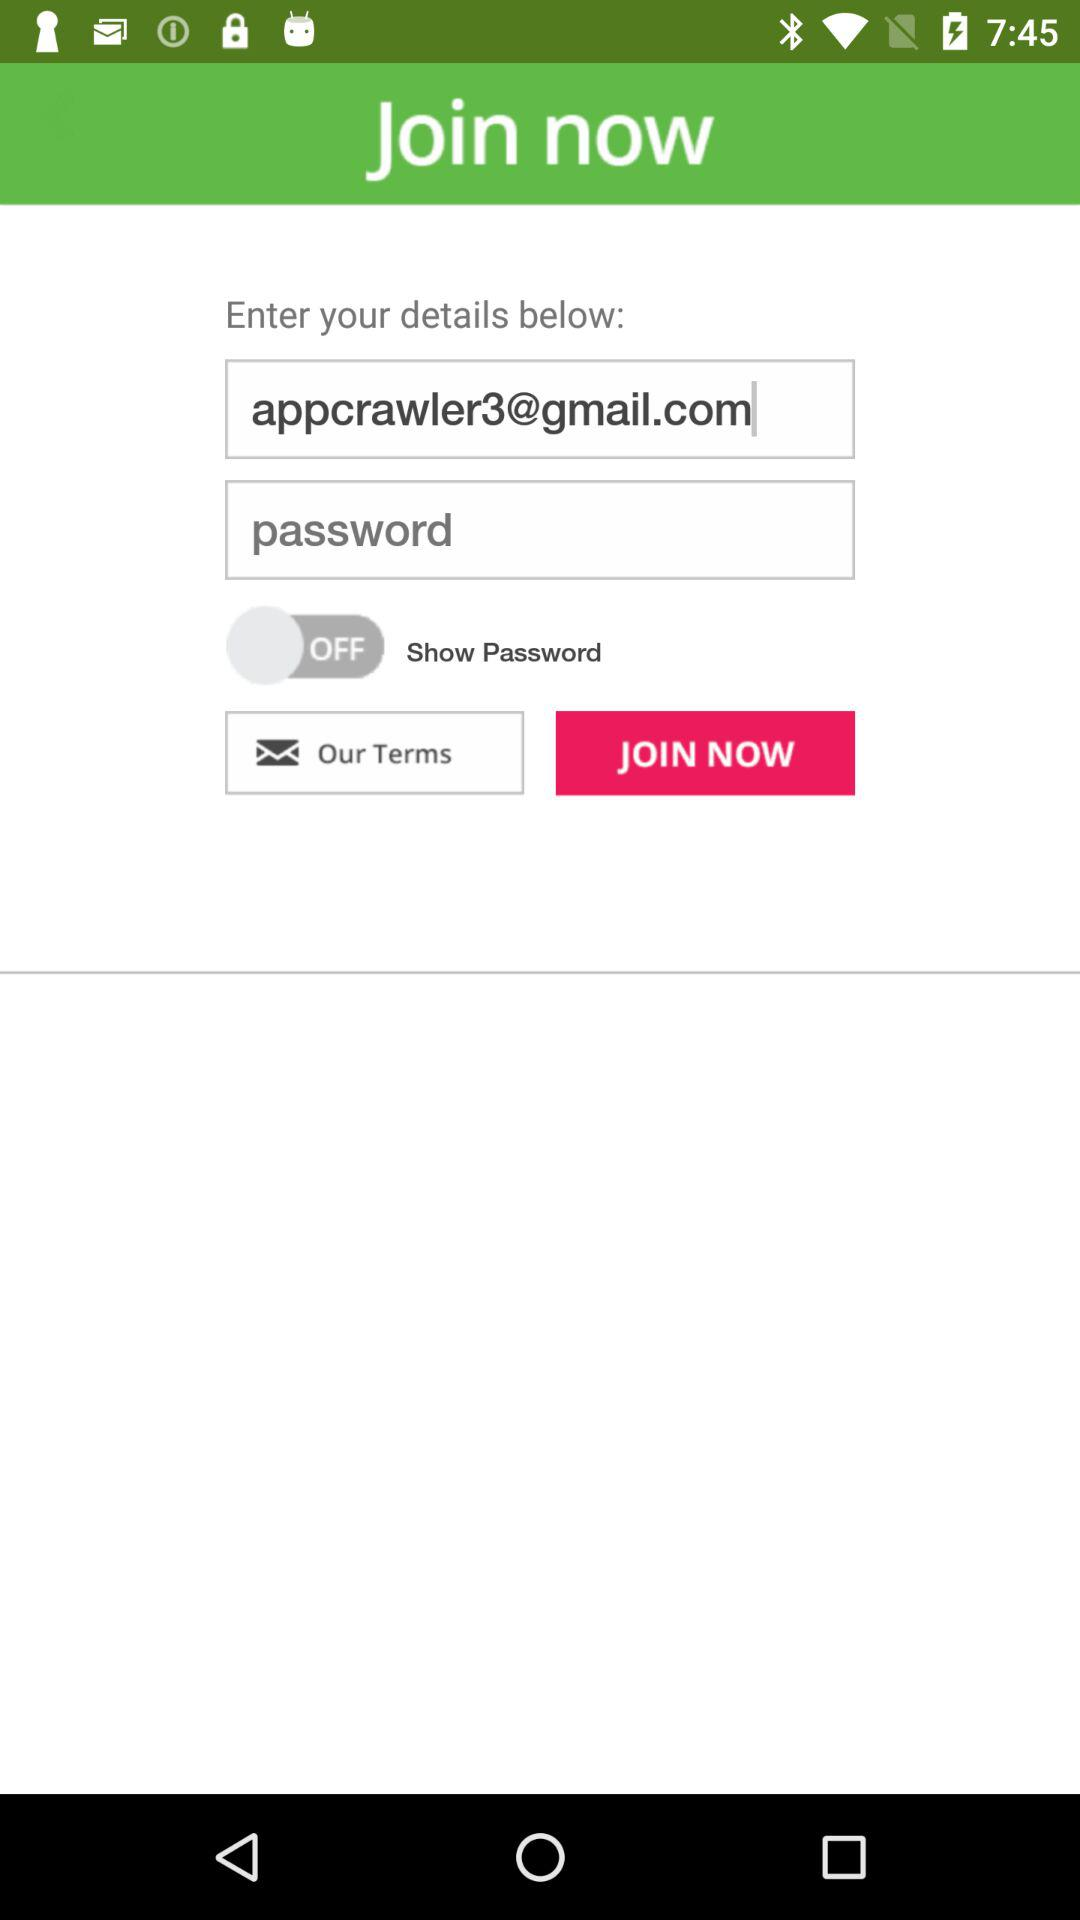What is the email address? The email address is appcrawler3@gmail.com. 